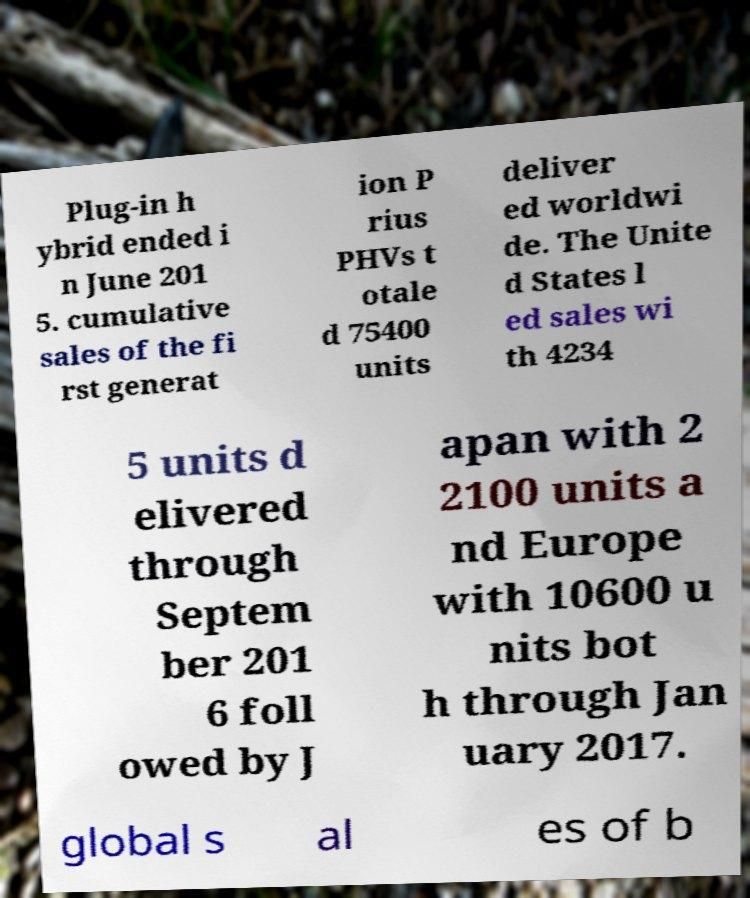For documentation purposes, I need the text within this image transcribed. Could you provide that? Plug-in h ybrid ended i n June 201 5. cumulative sales of the fi rst generat ion P rius PHVs t otale d 75400 units deliver ed worldwi de. The Unite d States l ed sales wi th 4234 5 units d elivered through Septem ber 201 6 foll owed by J apan with 2 2100 units a nd Europe with 10600 u nits bot h through Jan uary 2017. global s al es of b 